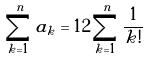Convert formula to latex. <formula><loc_0><loc_0><loc_500><loc_500>\sum _ { k = 1 } ^ { n } a _ { k } = 1 2 \sum _ { k = 1 } ^ { n } \frac { 1 } { k ! }</formula> 